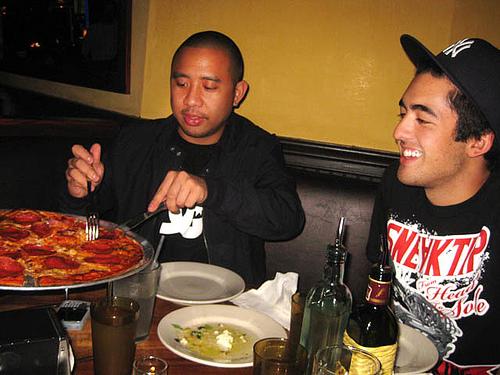Is this in a pizza place?
Write a very short answer. Yes. What is on the back of his booth?
Keep it brief. Wall. What is on the man's head?
Give a very brief answer. Hat. What is the man cutting the pizza with?
Write a very short answer. Knife and fork. 